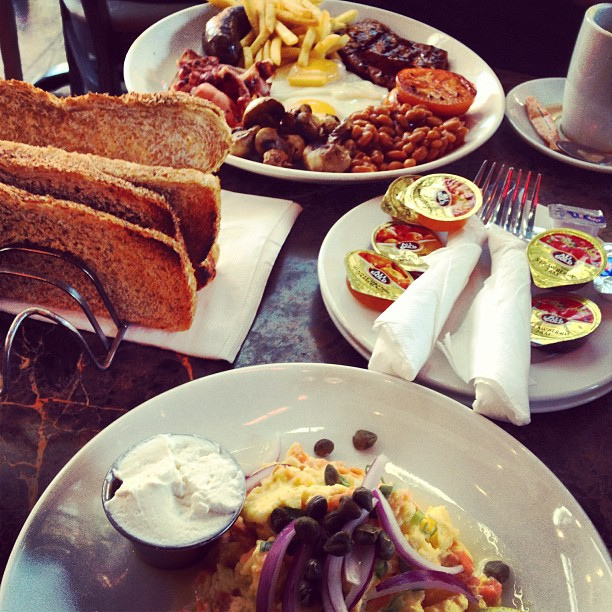Let's create a realistic scenario: Why might someone choose this hearty breakfast? Someone might choose this hearty breakfast to kickstart their day with a meal that will keep them full and energized. The combination of protein, carbohydrates, and fats ensures that they have enough energy for a busy morning ahead, whether it's for a long workday or a day filled with activities. 